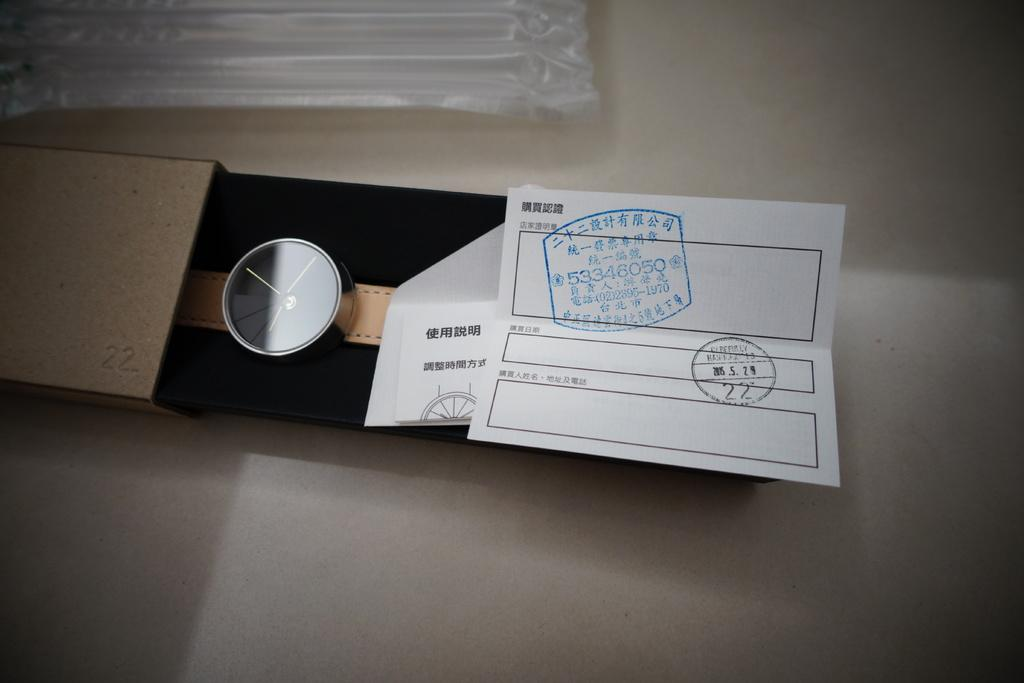What object is in the image that is used for telling time? There is a watch in the image. Where is the watch located? The watch is in a box. What type of paper is present in the image? There is a white color paper with text in the image. What color is the surface at the bottom of the image? There is a white color surface at the bottom of the image. Can you see any birds flying over the watch in the image? There are no birds present in the image. 